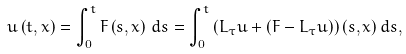<formula> <loc_0><loc_0><loc_500><loc_500>u \left ( t , x \right ) = \int _ { 0 } ^ { t } F \left ( s , x \right ) \, d s = \int _ { 0 } ^ { t } \left ( L _ { \tau } u + ( F - L _ { \tau } u ) \right ) ( s , x ) \, d s ,</formula> 